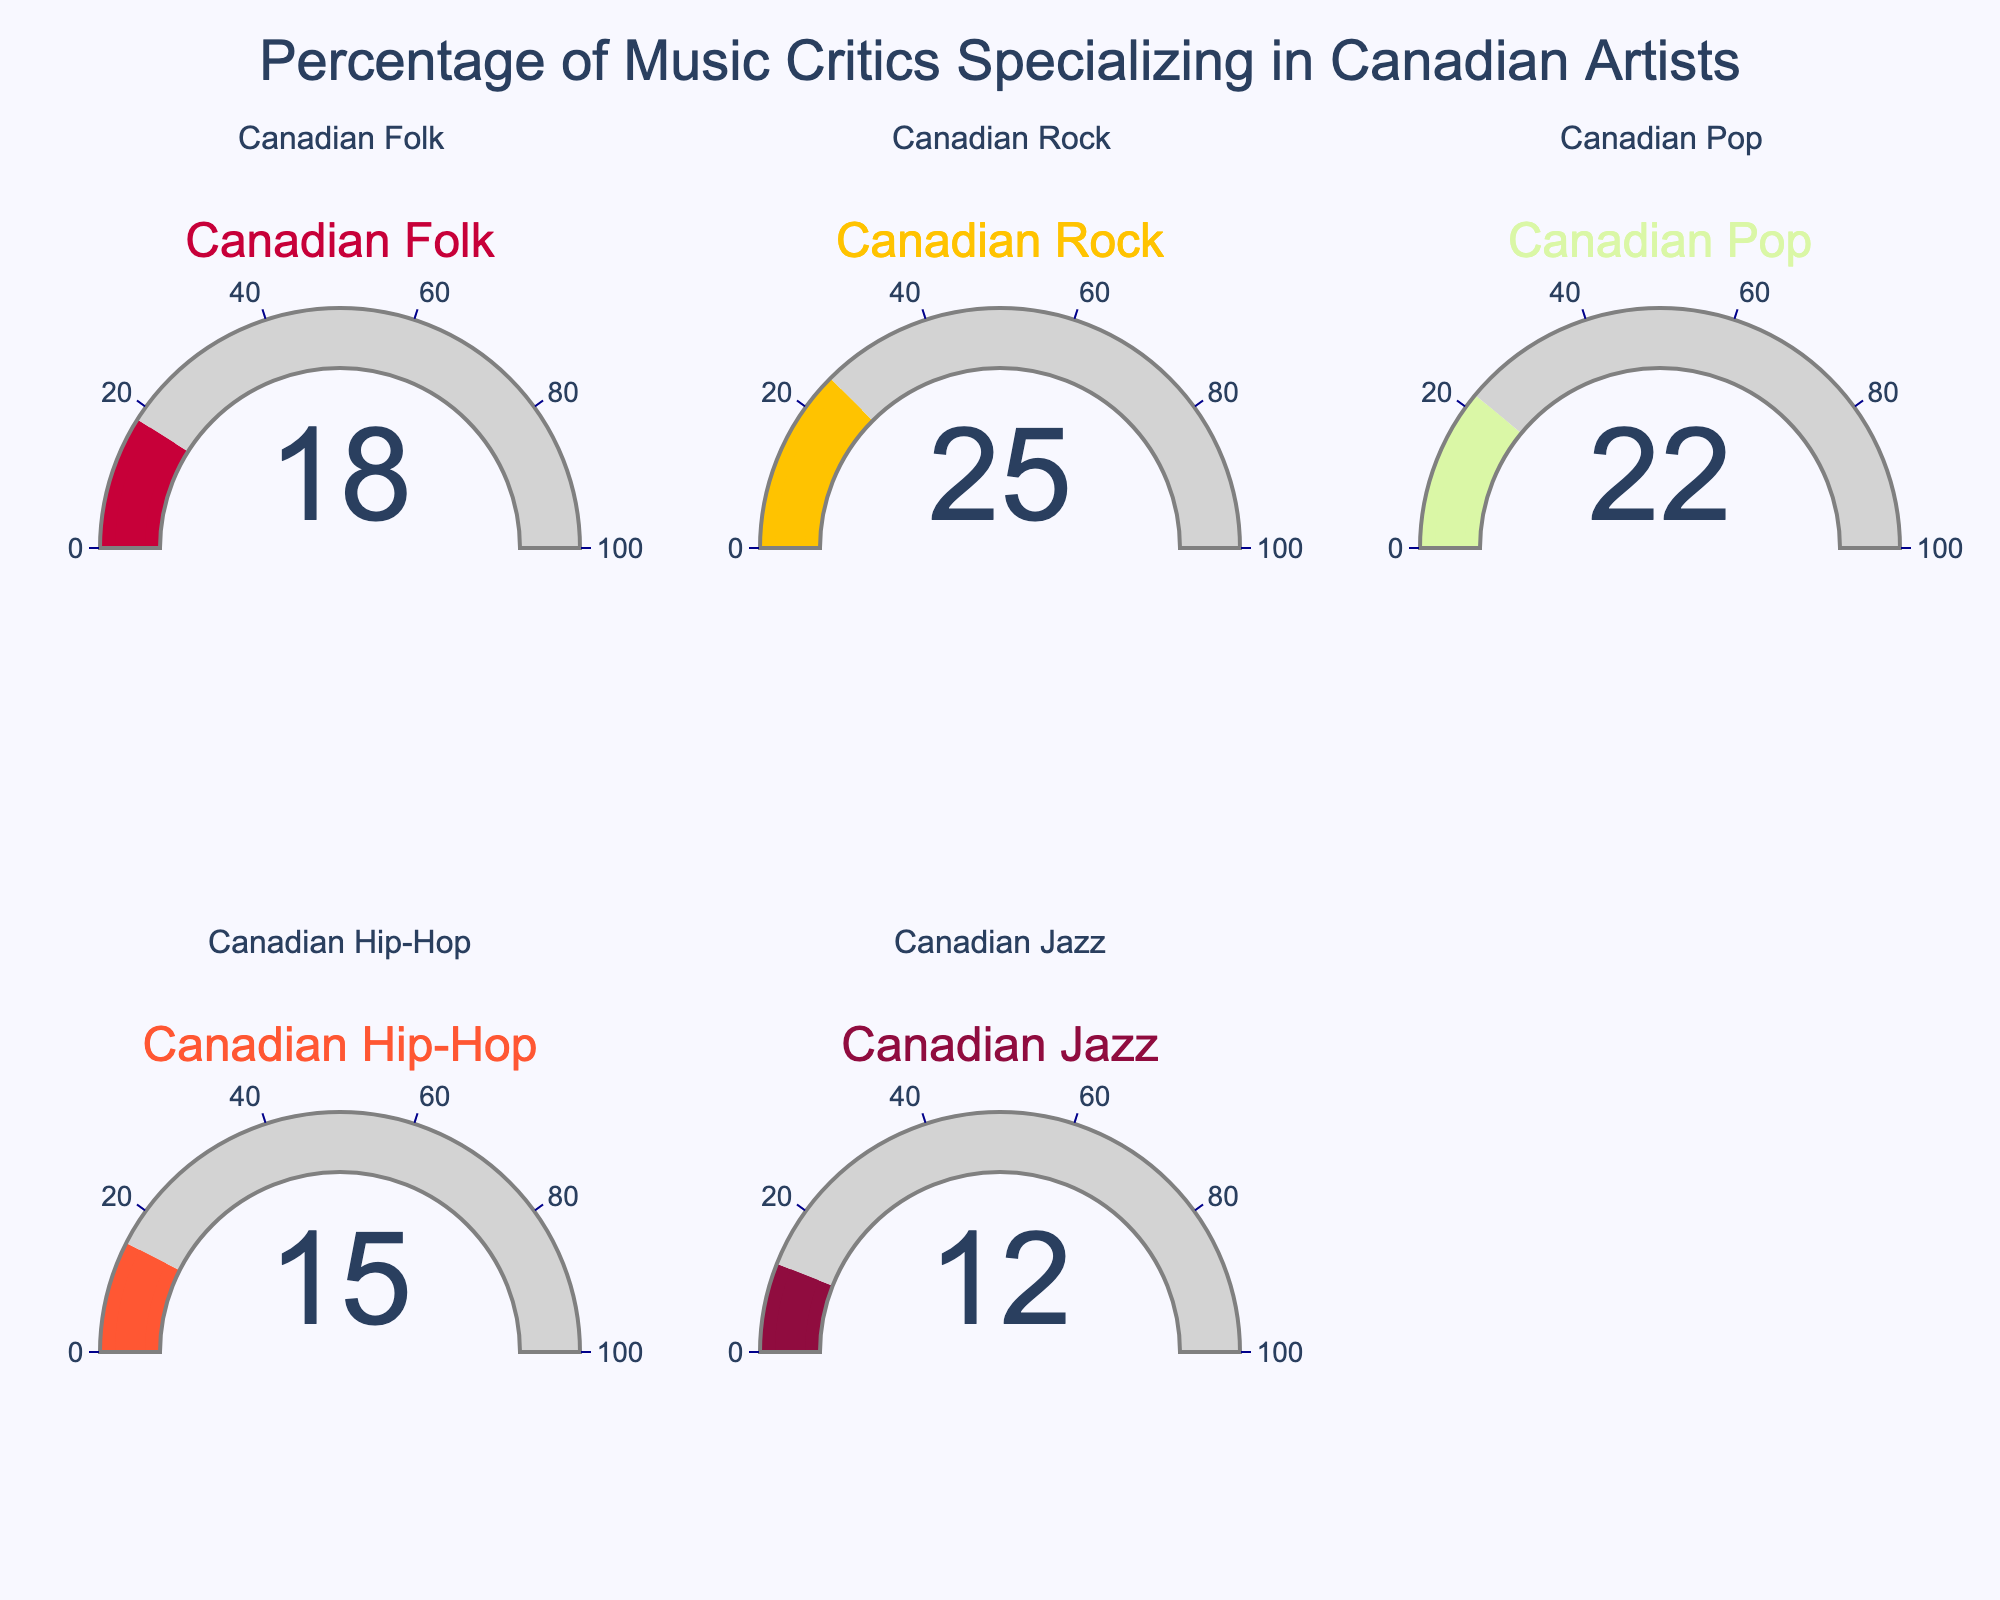What's the percentage of music critics specializing in Canadian Rock? The figure clearly shows the percentage for each category. For Canadian Rock, the gauge indicates the specific value.
Answer: 25% How many categories have a percentage higher than 20%? Observing each gauge, Canadian Folk has 18%, Canadian Rock has 25%, Canadian Pop has 22%, Canadian Hip-Hop has 15%, and Canadian Jazz has 12%. The categories above 20% are Canadian Rock and Canadian Pop.
Answer: 2 Which category has the least percentage of music critics specialized in it? By comparing the values on each gauge, we see that Canadian Jazz has the smallest percentage, which is 12%.
Answer: Canadian Jazz What's the total combined percentage for Canadian Folk and Canadian Pop critics? The percentage for Canadian Folk is 18%, and for Canadian Pop, it is 22%. Adding these gives 18% + 22% = 40%.
Answer: 40% What's the difference in percentage between Canadian Rock and Canadian Hip-Hop critics? The percentage for Canadian Rock is 25%, and for Canadian Hip-Hop, it is 15%. The difference is 25% - 15% = 10%.
Answer: 10% What is the average percentage of music critics across all categories? Add all the percentage values and divide by the number of categories: (18 + 25 + 22 + 15 + 12) / 5 = 92 / 5 = 18.4%.
Answer: 18.4% Which category has the second-highest percentage of music critics? By examining the values, Canadian Rock has the highest at 25%, and Canadian Pop follows it with 22%.
Answer: Canadian Pop Is the percentage of Canadian Jazz critics more or less than half the percentage of Canadian Rock critics? Canadian Rock is 25%. Half of 25% is 12.5%. Canadian Jazz is 12%, which is less than 12.5%.
Answer: Less Between Canadian Folk and Canadian Hip-Hop, which has a higher percentage of specialized music critics? Comparing the values, Canadian Folk has 18%, and Canadian Hip-Hop has 15%. Thus, Canadian Folk has a higher percentage.
Answer: Canadian Folk If we consider a threshold of 20%, how many categories fall below this threshold? Checking each value: Canadian Folk (18%), Canadian Rock (25%), Canadian Pop (22%), Canadian Hip-Hop (15%), Canadian Jazz (12%). Categories below 20% are Canadian Folk, Canadian Hip-Hop, and Canadian Jazz.
Answer: 3 